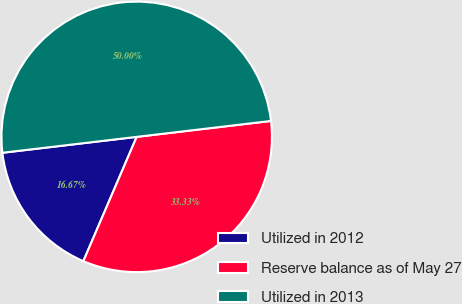Convert chart to OTSL. <chart><loc_0><loc_0><loc_500><loc_500><pie_chart><fcel>Utilized in 2012<fcel>Reserve balance as of May 27<fcel>Utilized in 2013<nl><fcel>16.67%<fcel>33.33%<fcel>50.0%<nl></chart> 